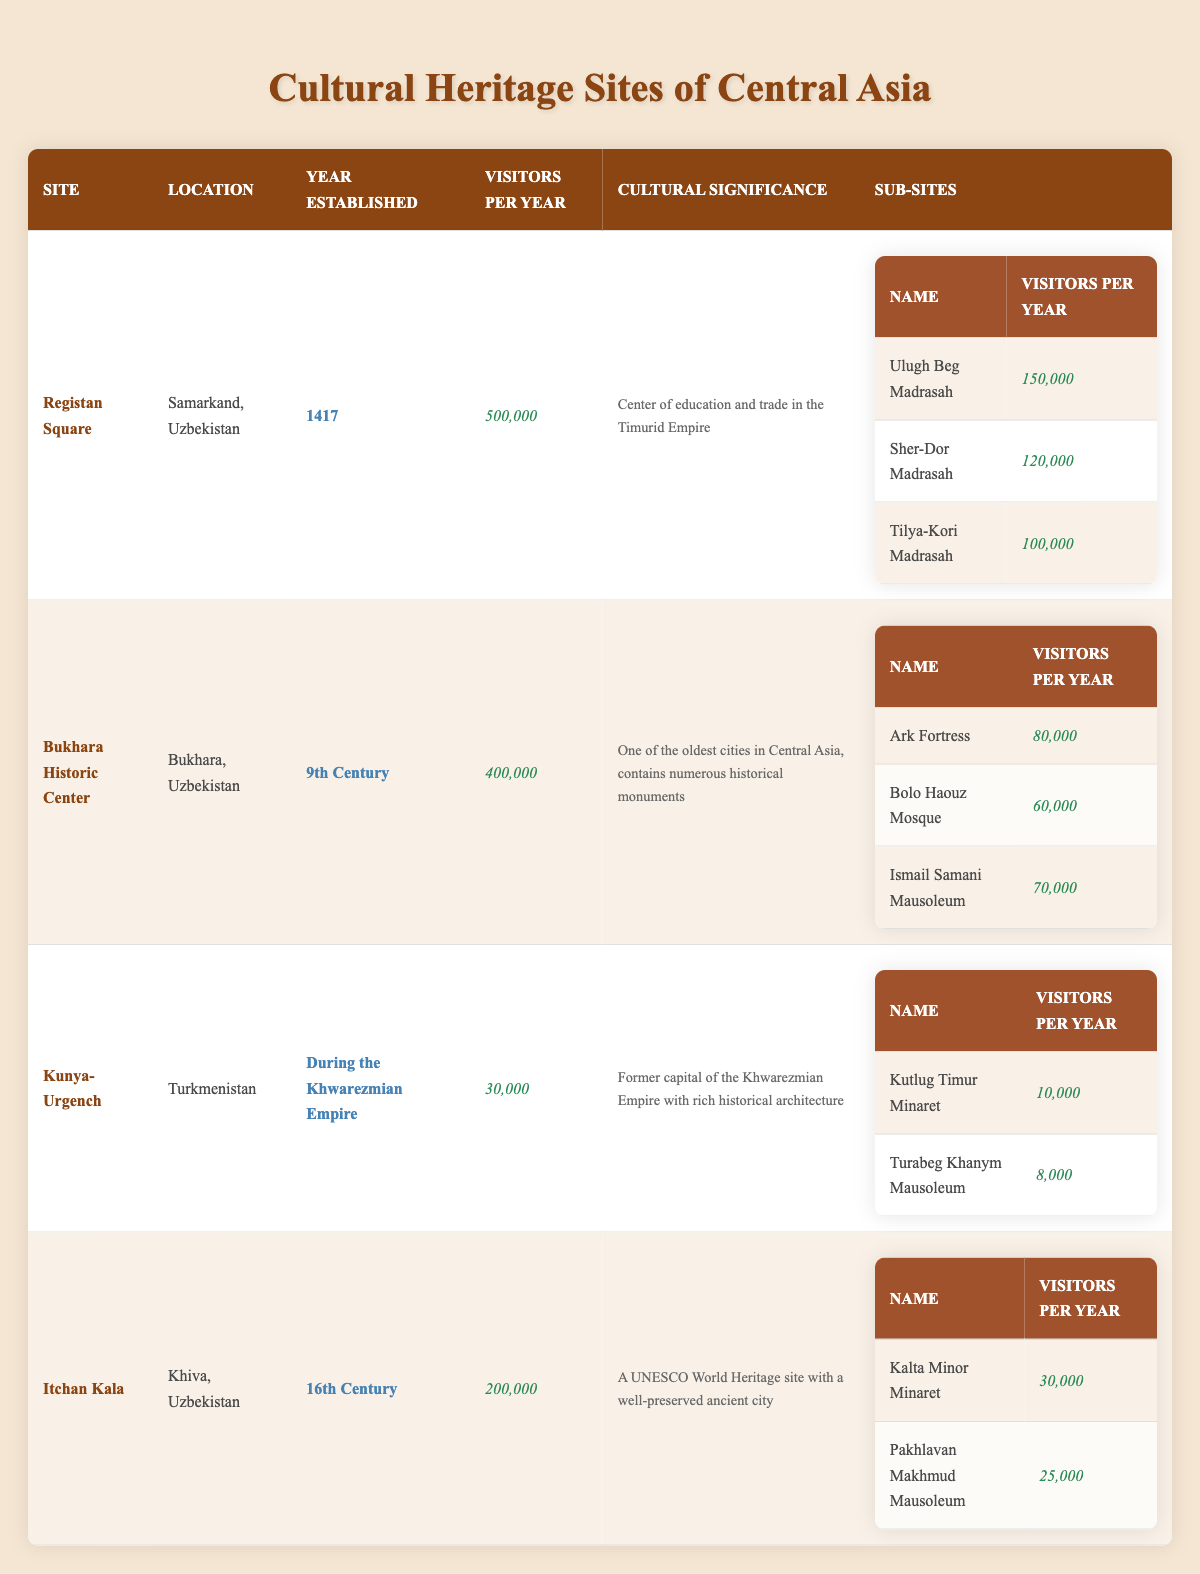What is the total number of visitors per year for Registan Square? The table shows that Registan Square receives 500,000 visitors per year.
Answer: 500,000 Which site has the highest number of visitors per year? The data indicates that Registan Square has 500,000 visitors, which is more than any other site listed.
Answer: Registan Square How many visitors does the Itchan Kala receive compared to Kunya-Urgench? Itchan Kala receives 200,000 visitors while Kunya-Urgench receives 30,000 visitors. The difference is (200,000 - 30,000) = 170,000.
Answer: 170,000 Is the Bukhara Historic Center older than Itchan Kala? Bukhara Historic Center was established in the 9th century, while Itchan Kala was established in the 16th century, making Bukhara older.
Answer: Yes What is the combined number of visitors for all the sub-sites of Registan Square? The sub-sites of Registan Square are Ulugh Beg Madrasah (150,000), Sher-Dor Madrasah (120,000), and Tilya-Kori Madrasah (100,000). Adding these gives (150,000 + 120,000 + 100,000) = 370,000 visitors for all sub-sites.
Answer: 370,000 Which site has fewer visitors: Kunya-Urgench or Itchan Kala? Kunya-Urgench has 30,000 visitors while Itchan Kala has 200,000 visitors. Clearly, Kunya-Urgench has fewer visitors.
Answer: Kunya-Urgench By how much do the visitors of Bukhara Historic Center exceed the visitors of Kunya-Urgench? Bukhara Historic Center has 400,000 visitors, and Kunya-Urgench has 30,000 visitors. The difference is (400,000 - 30,000) = 370,000.
Answer: 370,000 Is the Ark Fortress one of the sub-sites under Registan Square? The Ark Fortress is listed as a sub-site of Bukhara Historic Center, not Registan Square.
Answer: No 